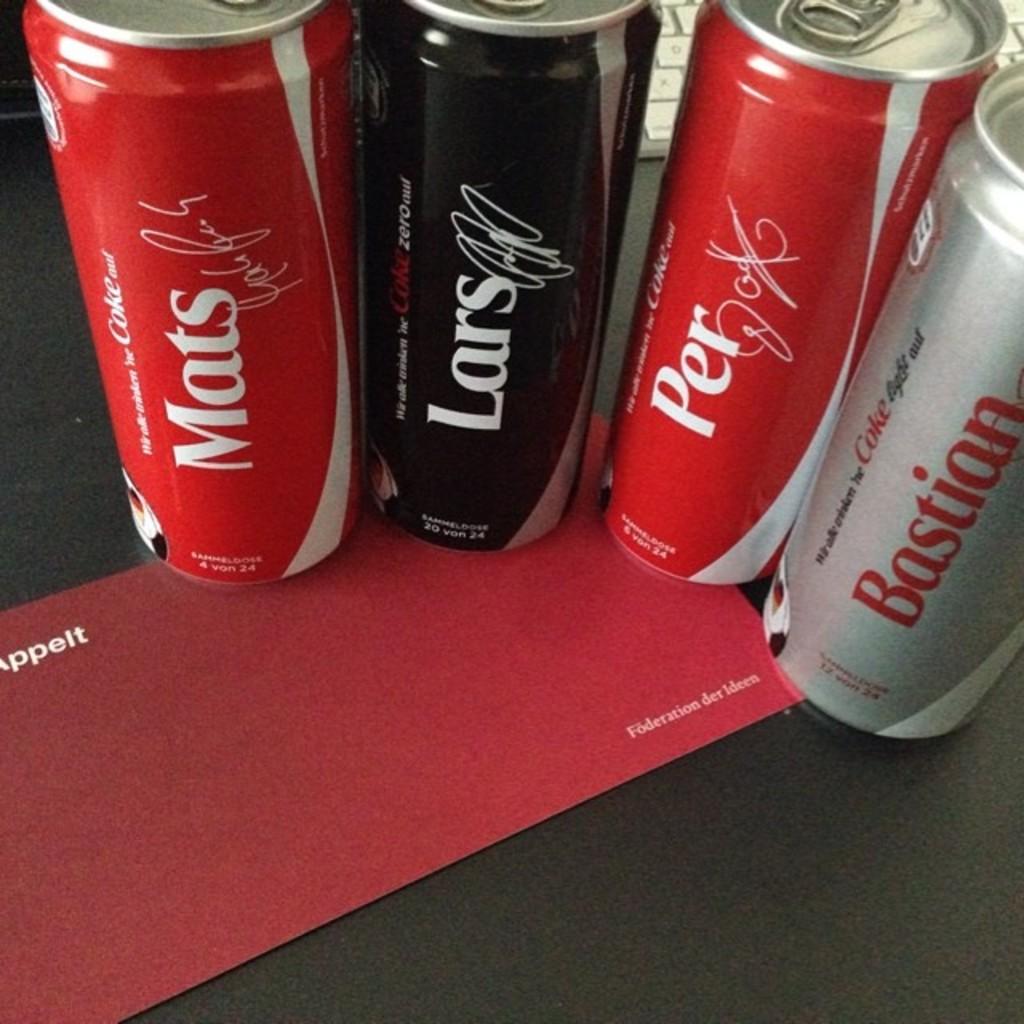What name is on the can to the far right?
Your response must be concise. Bastian. What name is on the black can?
Offer a very short reply. Lars. 